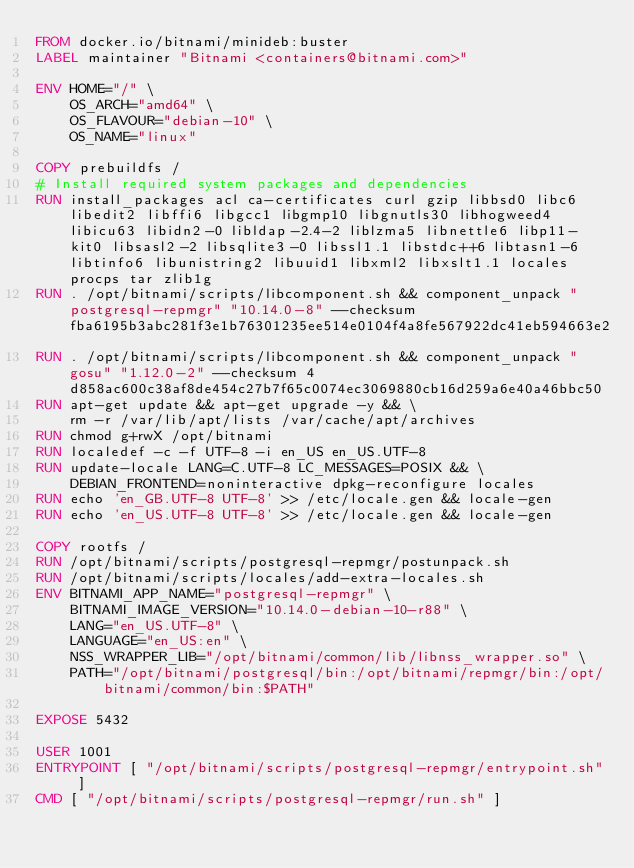Convert code to text. <code><loc_0><loc_0><loc_500><loc_500><_Dockerfile_>FROM docker.io/bitnami/minideb:buster
LABEL maintainer "Bitnami <containers@bitnami.com>"

ENV HOME="/" \
    OS_ARCH="amd64" \
    OS_FLAVOUR="debian-10" \
    OS_NAME="linux"

COPY prebuildfs /
# Install required system packages and dependencies
RUN install_packages acl ca-certificates curl gzip libbsd0 libc6 libedit2 libffi6 libgcc1 libgmp10 libgnutls30 libhogweed4 libicu63 libidn2-0 libldap-2.4-2 liblzma5 libnettle6 libp11-kit0 libsasl2-2 libsqlite3-0 libssl1.1 libstdc++6 libtasn1-6 libtinfo6 libunistring2 libuuid1 libxml2 libxslt1.1 locales procps tar zlib1g
RUN . /opt/bitnami/scripts/libcomponent.sh && component_unpack "postgresql-repmgr" "10.14.0-8" --checksum fba6195b3abc281f3e1b76301235ee514e0104f4a8fe567922dc41eb594663e2
RUN . /opt/bitnami/scripts/libcomponent.sh && component_unpack "gosu" "1.12.0-2" --checksum 4d858ac600c38af8de454c27b7f65c0074ec3069880cb16d259a6e40a46bbc50
RUN apt-get update && apt-get upgrade -y && \
    rm -r /var/lib/apt/lists /var/cache/apt/archives
RUN chmod g+rwX /opt/bitnami
RUN localedef -c -f UTF-8 -i en_US en_US.UTF-8
RUN update-locale LANG=C.UTF-8 LC_MESSAGES=POSIX && \
    DEBIAN_FRONTEND=noninteractive dpkg-reconfigure locales
RUN echo 'en_GB.UTF-8 UTF-8' >> /etc/locale.gen && locale-gen
RUN echo 'en_US.UTF-8 UTF-8' >> /etc/locale.gen && locale-gen

COPY rootfs /
RUN /opt/bitnami/scripts/postgresql-repmgr/postunpack.sh
RUN /opt/bitnami/scripts/locales/add-extra-locales.sh
ENV BITNAMI_APP_NAME="postgresql-repmgr" \
    BITNAMI_IMAGE_VERSION="10.14.0-debian-10-r88" \
    LANG="en_US.UTF-8" \
    LANGUAGE="en_US:en" \
    NSS_WRAPPER_LIB="/opt/bitnami/common/lib/libnss_wrapper.so" \
    PATH="/opt/bitnami/postgresql/bin:/opt/bitnami/repmgr/bin:/opt/bitnami/common/bin:$PATH"

EXPOSE 5432

USER 1001
ENTRYPOINT [ "/opt/bitnami/scripts/postgresql-repmgr/entrypoint.sh" ]
CMD [ "/opt/bitnami/scripts/postgresql-repmgr/run.sh" ]
</code> 